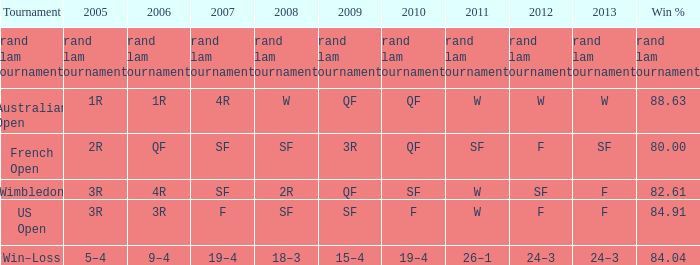In 2007, what has a 2008 related to science fiction and a 2010 associated with fantasy? F. 